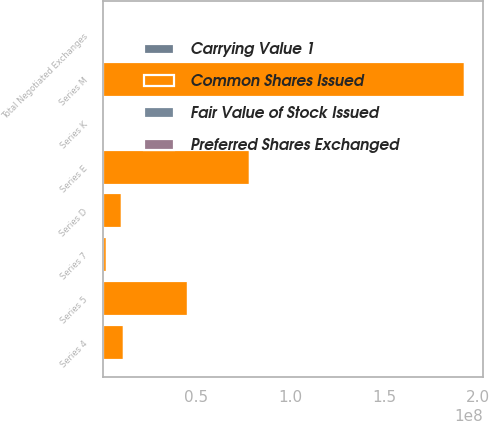<chart> <loc_0><loc_0><loc_500><loc_500><stacked_bar_chart><ecel><fcel>Series K<fcel>Series M<fcel>Series 4<fcel>Series D<fcel>Series 7<fcel>Total Negotiated Exchanges<fcel>Series E<fcel>Series 5<nl><fcel>Fair Value of Stock Issued<fcel>173298<fcel>102643<fcel>7024<fcel>6566<fcel>33404<fcel>322935<fcel>61509<fcel>29810<nl><fcel>Preferred Shares Exchanged<fcel>4332<fcel>2566<fcel>211<fcel>164<fcel>33<fcel>7306<fcel>1538<fcel>894<nl><fcel>Common Shares Issued<fcel>6323.5<fcel>1.9297e+08<fcel>1.16422e+07<fcel>1.01048e+07<fcel>2.06905e+06<fcel>6323.5<fcel>7.86705e+07<fcel>4.57535e+07<nl><fcel>Carrying Value 1<fcel>3635<fcel>2178<fcel>131<fcel>114<fcel>23<fcel>6081<fcel>1003<fcel>583<nl></chart> 